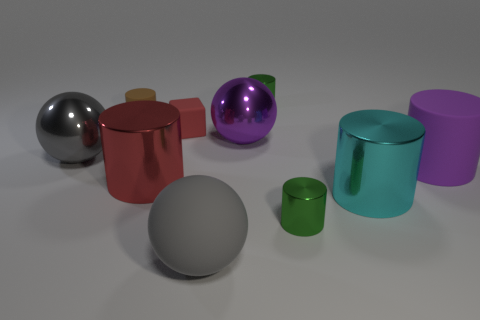Subtract all gray spheres. How many spheres are left? 1 Subtract all brown cylinders. How many gray spheres are left? 2 Subtract all brown cylinders. How many cylinders are left? 5 Subtract 3 cylinders. How many cylinders are left? 3 Subtract all cylinders. How many objects are left? 4 Subtract all cyan cylinders. Subtract all purple cubes. How many cylinders are left? 5 Subtract all shiny cylinders. Subtract all large shiny things. How many objects are left? 2 Add 1 small green objects. How many small green objects are left? 3 Add 6 green metallic cylinders. How many green metallic cylinders exist? 8 Subtract 0 purple blocks. How many objects are left? 10 